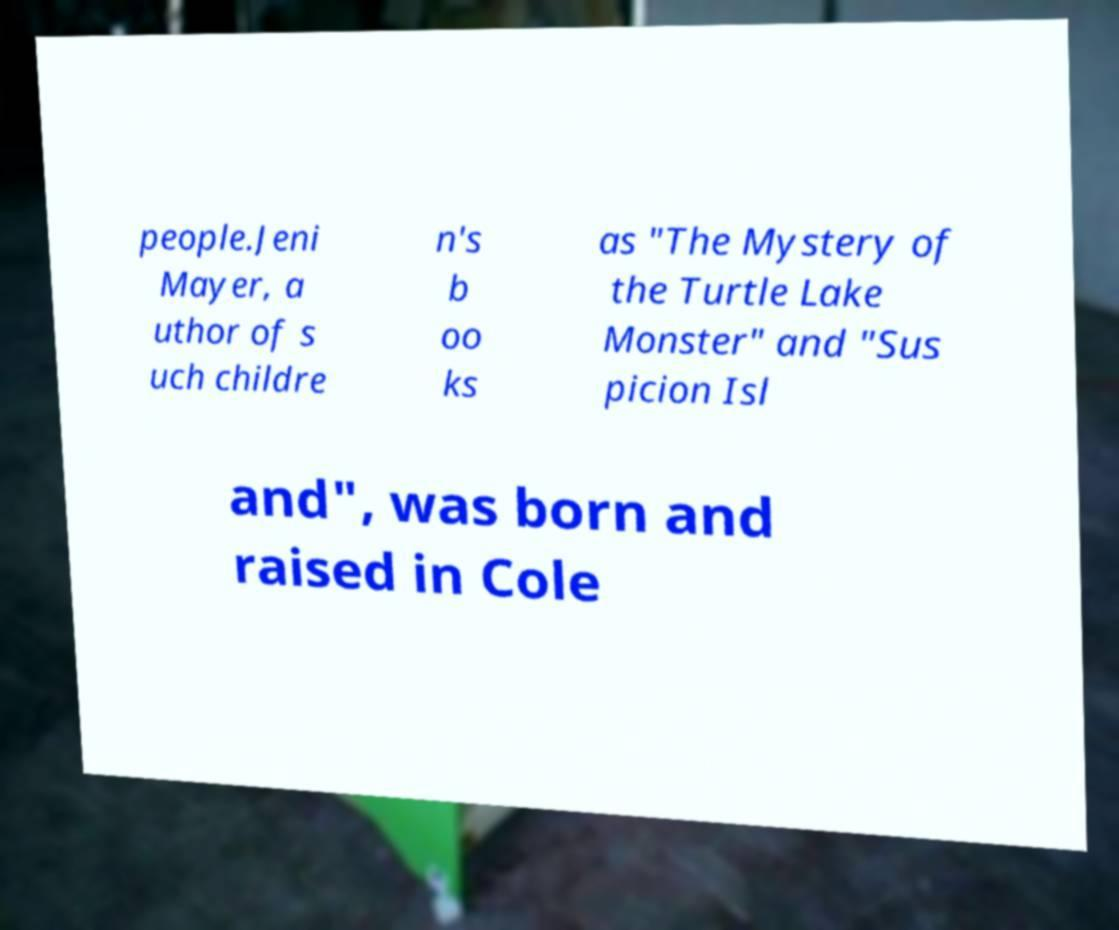What messages or text are displayed in this image? I need them in a readable, typed format. people.Jeni Mayer, a uthor of s uch childre n's b oo ks as "The Mystery of the Turtle Lake Monster" and "Sus picion Isl and", was born and raised in Cole 